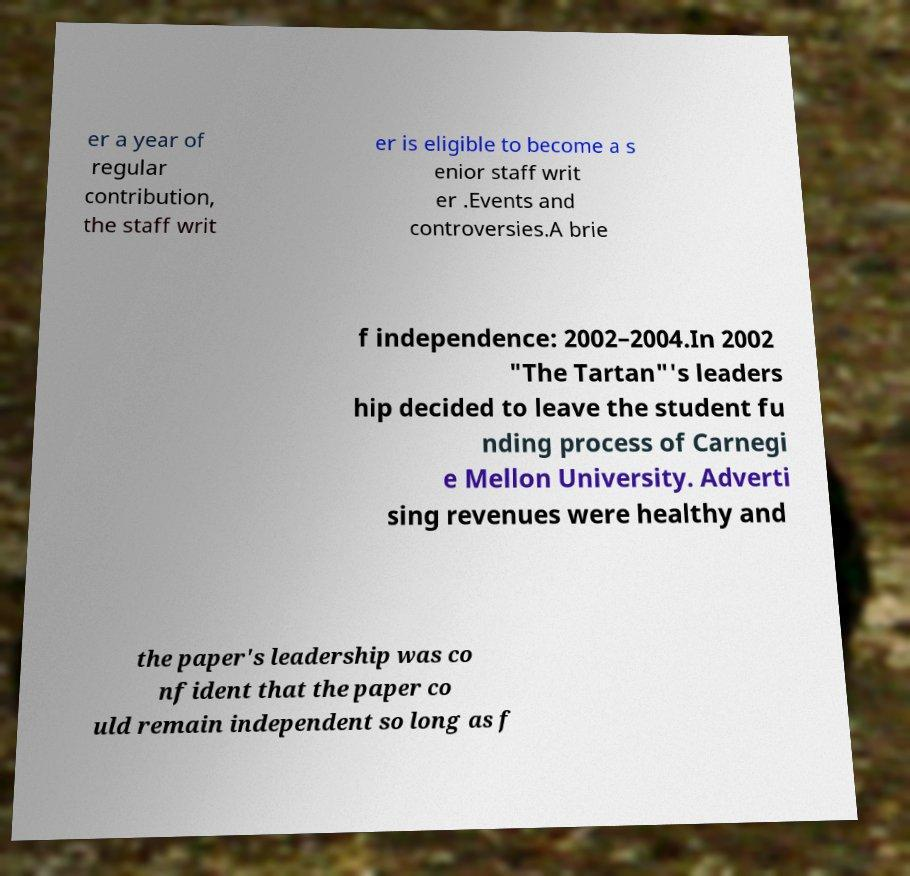Can you read and provide the text displayed in the image?This photo seems to have some interesting text. Can you extract and type it out for me? er a year of regular contribution, the staff writ er is eligible to become a s enior staff writ er .Events and controversies.A brie f independence: 2002–2004.In 2002 "The Tartan"'s leaders hip decided to leave the student fu nding process of Carnegi e Mellon University. Adverti sing revenues were healthy and the paper's leadership was co nfident that the paper co uld remain independent so long as f 